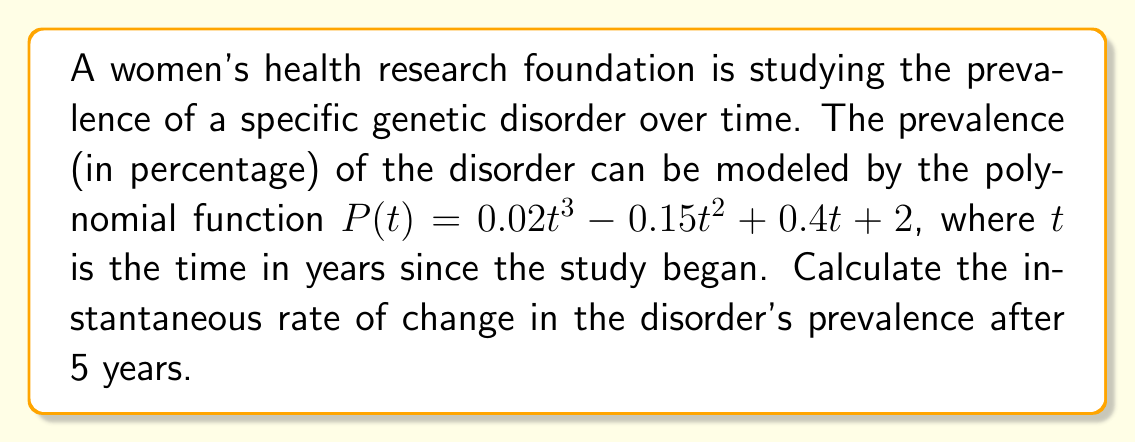Provide a solution to this math problem. To find the instantaneous rate of change at $t = 5$, we need to calculate the derivative of the polynomial function $P(t)$ and then evaluate it at $t = 5$.

Step 1: Find the derivative of $P(t)$
$$P(t) = 0.02t^3 - 0.15t^2 + 0.4t + 2$$
$$P'(t) = 0.06t^2 - 0.3t + 0.4$$

Step 2: Evaluate $P'(t)$ at $t = 5$
$$P'(5) = 0.06(5^2) - 0.3(5) + 0.4$$
$$= 0.06(25) - 1.5 + 0.4$$
$$= 1.5 - 1.5 + 0.4$$
$$= 0.4$$

The instantaneous rate of change after 5 years is 0.4 percentage points per year.
Answer: 0.4 percentage points/year 